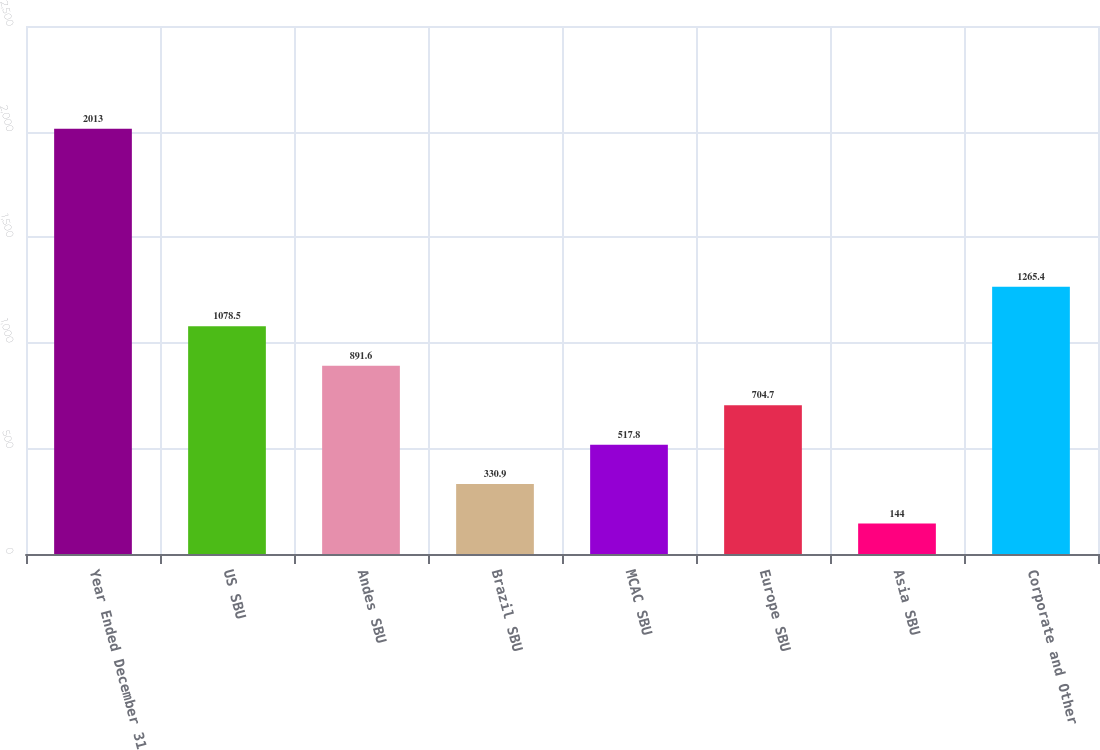<chart> <loc_0><loc_0><loc_500><loc_500><bar_chart><fcel>Year Ended December 31<fcel>US SBU<fcel>Andes SBU<fcel>Brazil SBU<fcel>MCAC SBU<fcel>Europe SBU<fcel>Asia SBU<fcel>Corporate and Other<nl><fcel>2013<fcel>1078.5<fcel>891.6<fcel>330.9<fcel>517.8<fcel>704.7<fcel>144<fcel>1265.4<nl></chart> 